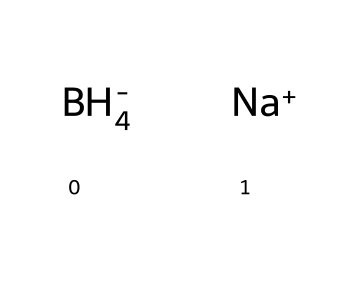What is the main element in sodium borohydride? The molecular structure displays the element boron (B) as a central part within the borohydride group, indicating it is the main element.
Answer: boron How many hydrogen atoms are present in sodium borohydride? In the structure, there are four hydrogen atoms (H) indicated, which are part of the borohydride ion.
Answer: four What type of ion is present along with borohydride in sodium borohydride? The structure shows a sodium ion (Na+) in association with the borohydride ion (BH4-), revealing that it is a cation.
Answer: cation What charge does the borohydride ion carry? The visual representation indicates that the borohydride ion (BH4-) carries a negative charge (-), as depicted in the formula notation.
Answer: negative How many total atoms are there in sodium borohydride? Analyzing the chemical, there are a total of six atoms: one sodium (Na), one boron (B), and four hydrogens (H), giving a cumulative count of six.
Answer: six What is the molecular formula for sodium borohydride? The structural representation leads to the conclusion that the molecular formula consists of one sodium (Na), one boron (B), and four hydrogens (H), which can be succinctly written as NaBH4.
Answer: NaBH4 What type of chemical bonding is primarily present in sodium borohydride? The presence of the boron and hydrogen indicates that the bonding primarily consists of covalent bonds, characterized by shared electrons in the formation of the borohydride ion.
Answer: covalent bonds 